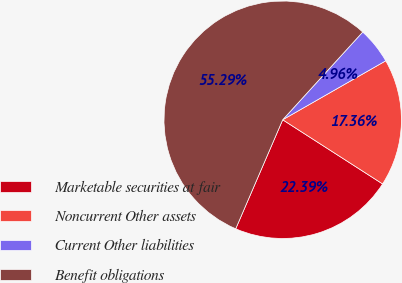Convert chart to OTSL. <chart><loc_0><loc_0><loc_500><loc_500><pie_chart><fcel>Marketable securities at fair<fcel>Noncurrent Other assets<fcel>Current Other liabilities<fcel>Benefit obligations<nl><fcel>22.39%<fcel>17.36%<fcel>4.96%<fcel>55.29%<nl></chart> 